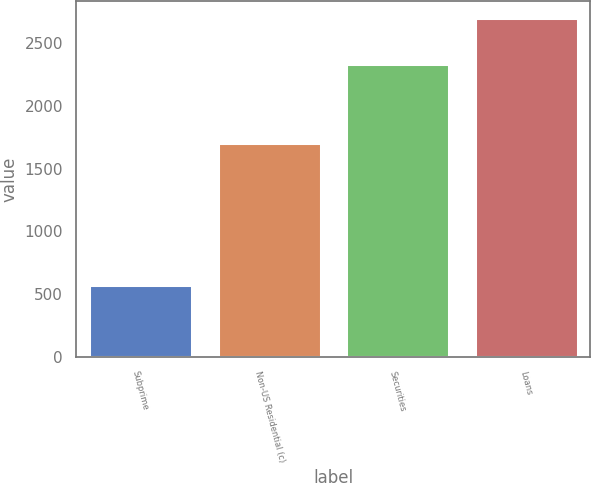Convert chart. <chart><loc_0><loc_0><loc_500><loc_500><bar_chart><fcel>Subprime<fcel>Non-US Residential (c)<fcel>Securities<fcel>Loans<nl><fcel>569<fcel>1702<fcel>2337<fcel>2699<nl></chart> 